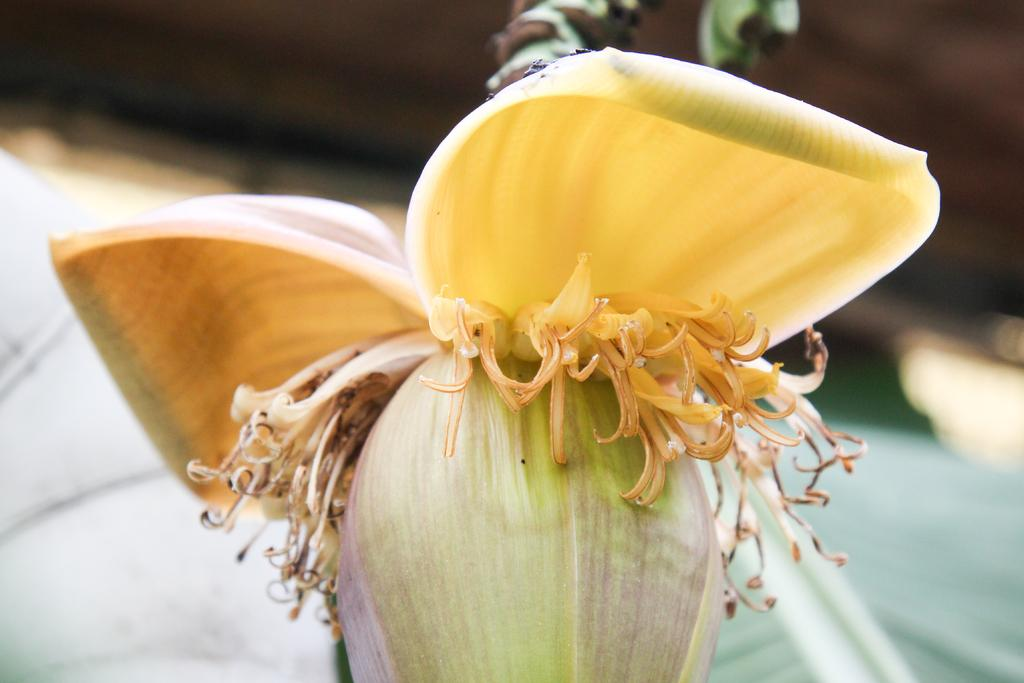What type of plant is featured in the image? There is a banana flower in the image. What type of transportation is shown in the image? There is no transportation present in the image; it features a banana flower. 